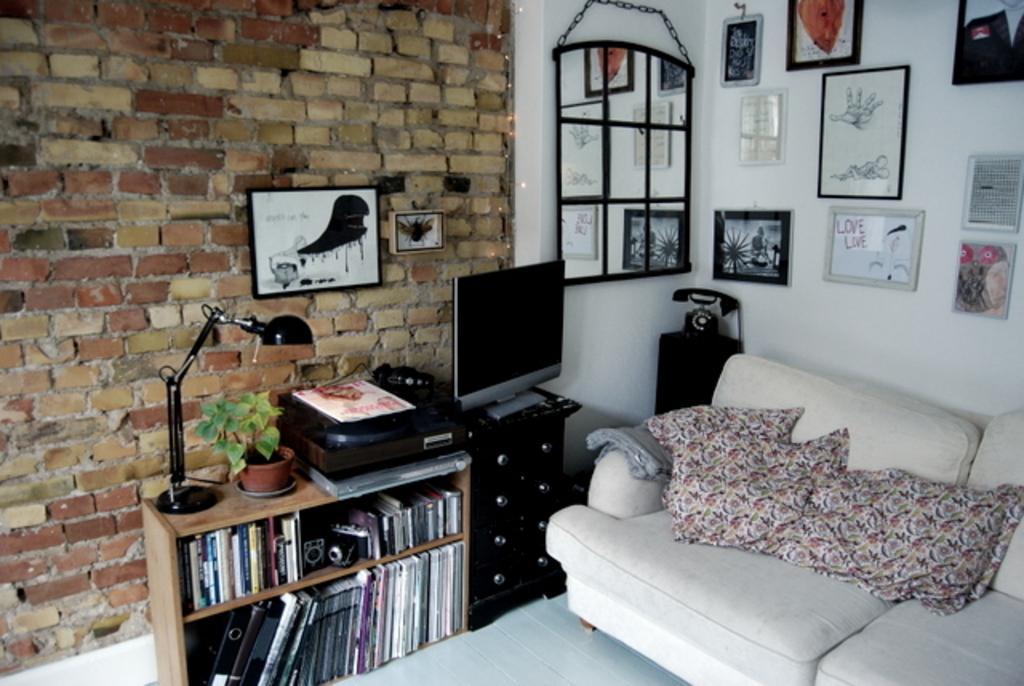Describe this image in one or two sentences. There are pillows on the sofa. Beside the sofa, there is a monitor and cupboard. Next to the monitor, there are books in the shelf's. On top of the cupboard, there is pot plant, light. In the background, there is a wall, photo frame on the wall, mirror, photo frames on the wall and a telephone on the cupboard. 